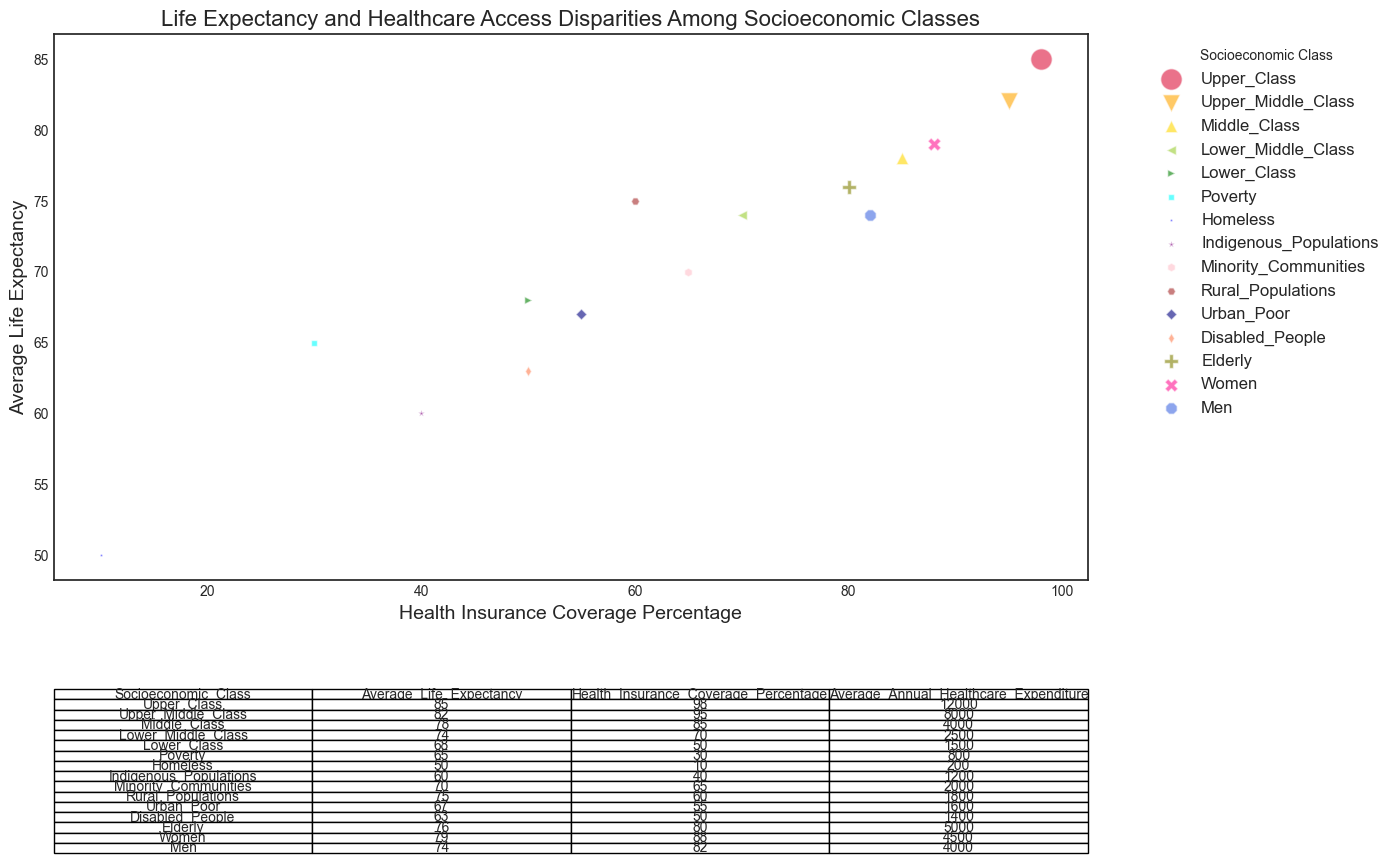What socioeconomic class has the highest average life expectancy? The plot shows that the 'Upper Class' has the point with the highest vertical position (average life expectancy), the other class values are lower.
Answer: Upper Class Which socioeconomic class has the lowest health insurance coverage percentage? According to the plot, the 'Homeless' segment has the point with the lowest position on the horizontal axis (health insurance coverage percentage), the other classes are higher.
Answer: Homeless How does the average life expectancy of 'Women' compare to 'Men'? 'Women' have a higher average life expectancy (79) than 'Men' (74), as seen from the vertical positioning of their respective points on the plot.
Answer: Women have a higher average life expectancy What is the difference in average annual healthcare expenditure between 'Upper Class' and 'Lower Class'? The table in the plot shows that the 'Upper Class' has an average annual healthcare expenditure of 12000, and the 'Lower Class' has 1500. The difference is 12000 - 1500 = 10500.
Answer: 10500 Are there any socioeconomic classes with health insurance coverage percentages between 85% and 90%? The plot does not show any points with health insurance coverage percentage within that range. The closest are 'Middle Class' with 85% and 'Women' with 88%, but none fall between.
Answer: No Which class has a life expectancy closest to 70 years? 'Minority Communities' have an average life expectancy of 70, as shown by the point on the vertical axis matching this value.
Answer: Minority Communities Which three classes have a healthcare expenditure of below 2000 and the highest life expectancy? By looking at the table and cross-referencing with the plot for those below 2000: 'Minority Communities' (70), 'Rural Populations' (75), and 'Urban Poor' (67). 'Rural Populations' has the highest among these, at 75.
Answer: Rural Populations, Minority Communities, Urban Poor What is the average healthcare expenditure of 'Upper Middle Class' and 'Middle Class'? The table reveals 'Upper Middle Class' at 8000 and 'Middle Class' at 4000. The average, then, is (8000 + 4000) / 2 = 6000.
Answer: 6000 Which class has both health insurance coverage and life expectancy in the bottom quartile? 'Homeless' have both the lowest health insurance coverage (10%) and life expectancy (50), the lowest of any class.
Answer: Homeless Compare the life expectancy of 'Elderly' and 'Disabled People' with one being higher. From the plot, 'Elderly' have a higher life expectancy of 76 compared to 'Disabled People' who have 63.
Answer: Elderly 